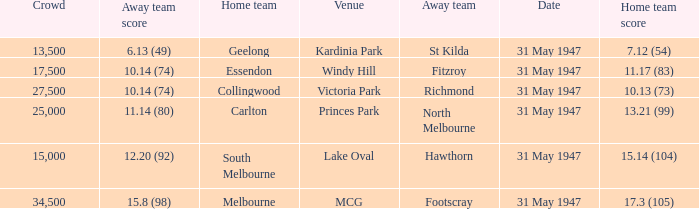What is the home team's score at mcg? 17.3 (105). 